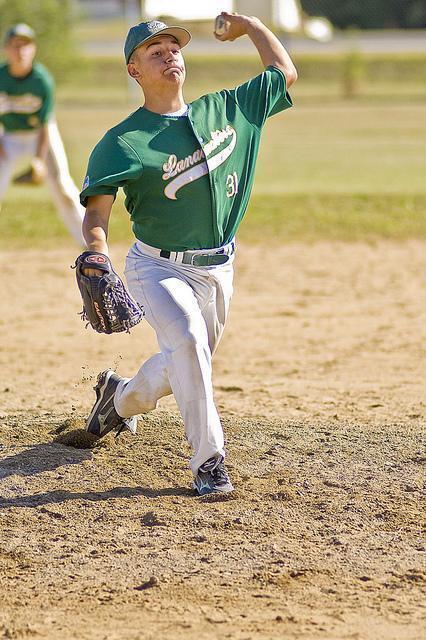Where does this man?
Select the accurate answer and provide explanation: 'Answer: answer
Rationale: rationale.'
Options: Dugout, home plate, outfield, pitchers mound. Answer: pitchers mound.
Rationale: The man is standing on the pitchers mound and throwing the ball. 